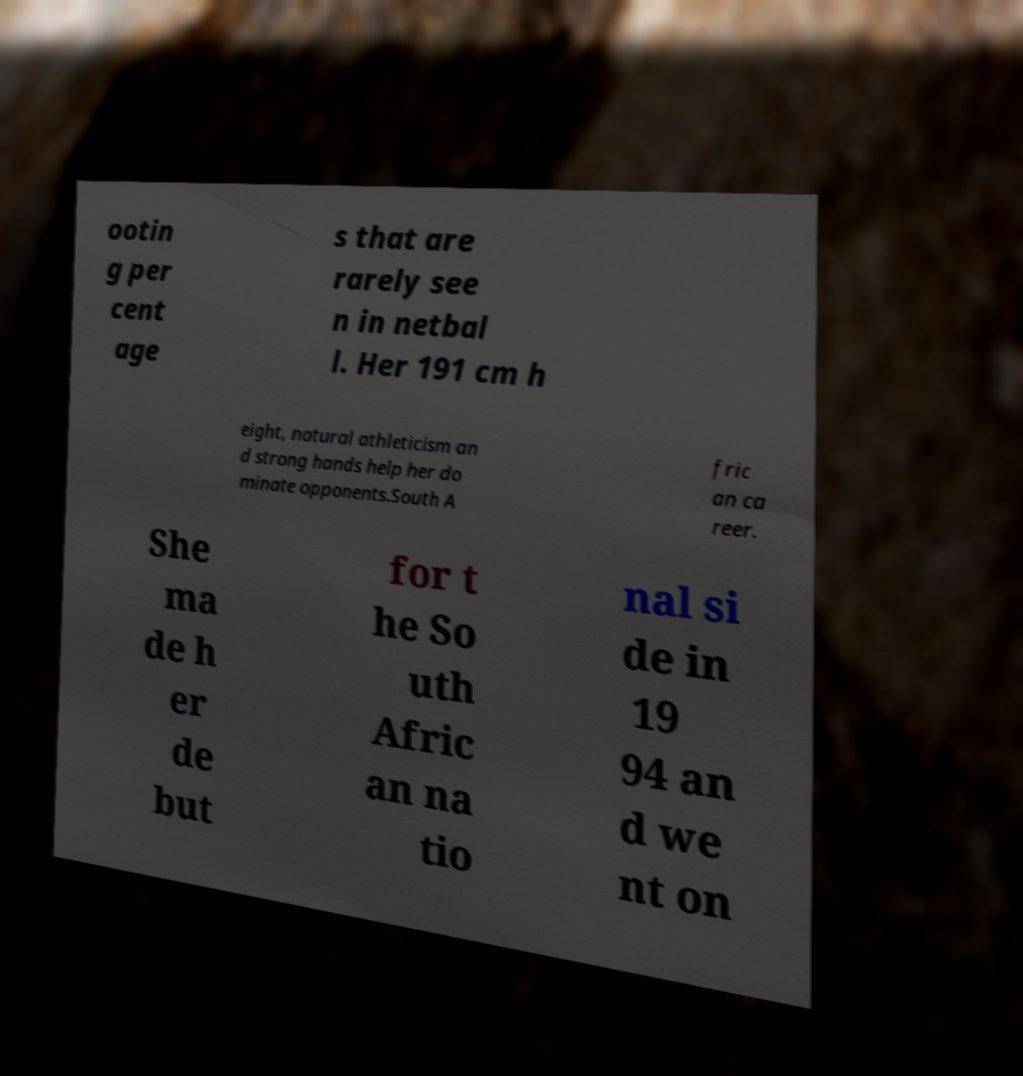Please identify and transcribe the text found in this image. ootin g per cent age s that are rarely see n in netbal l. Her 191 cm h eight, natural athleticism an d strong hands help her do minate opponents.South A fric an ca reer. She ma de h er de but for t he So uth Afric an na tio nal si de in 19 94 an d we nt on 